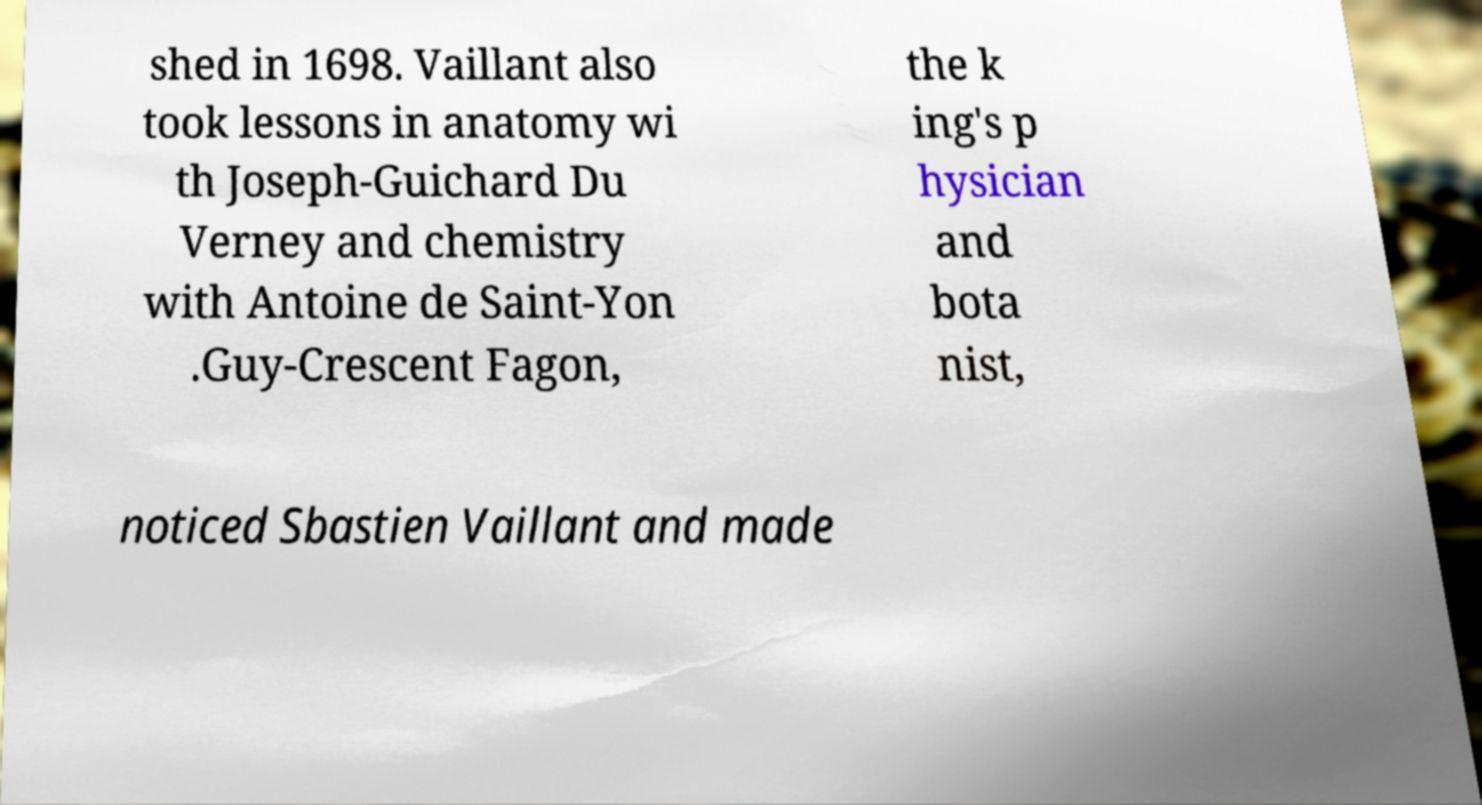Could you extract and type out the text from this image? shed in 1698. Vaillant also took lessons in anatomy wi th Joseph-Guichard Du Verney and chemistry with Antoine de Saint-Yon .Guy-Crescent Fagon, the k ing's p hysician and bota nist, noticed Sbastien Vaillant and made 